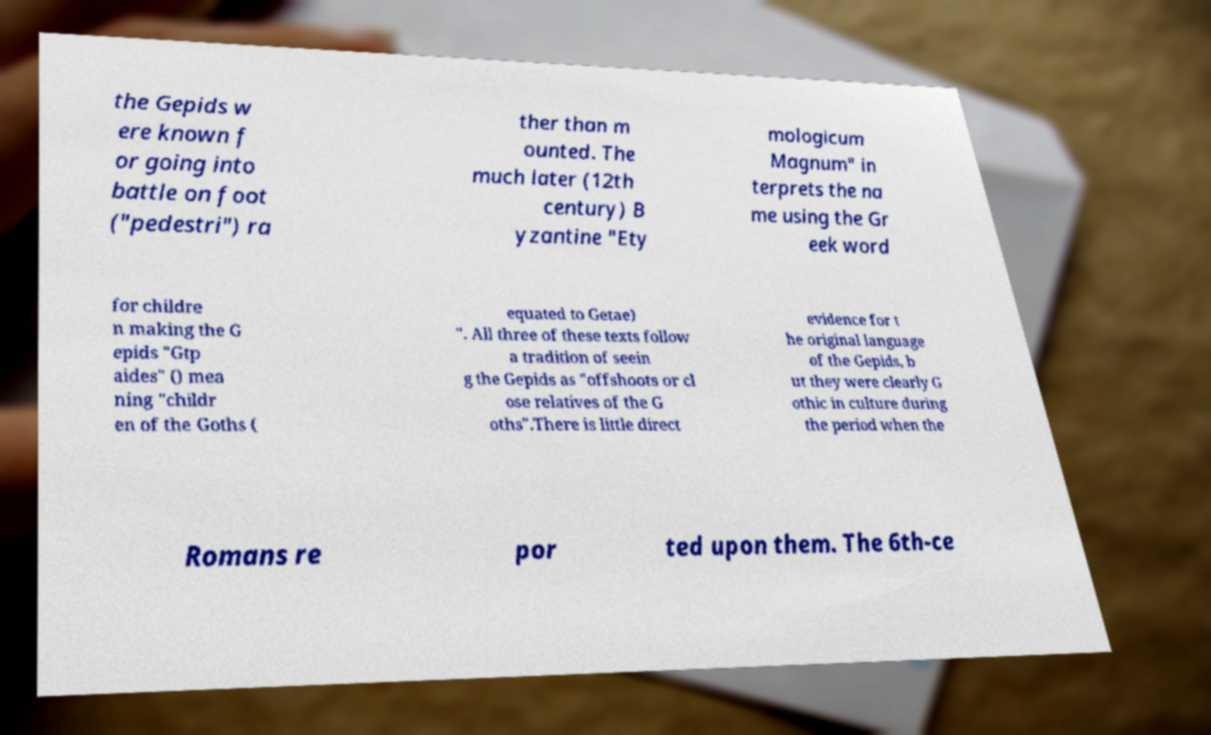Could you extract and type out the text from this image? the Gepids w ere known f or going into battle on foot ("pedestri") ra ther than m ounted. The much later (12th century) B yzantine "Ety mologicum Magnum" in terprets the na me using the Gr eek word for childre n making the G epids "Gtp aides" () mea ning "childr en of the Goths ( equated to Getae) ". All three of these texts follow a tradition of seein g the Gepids as "offshoots or cl ose relatives of the G oths".There is little direct evidence for t he original language of the Gepids, b ut they were clearly G othic in culture during the period when the Romans re por ted upon them. The 6th-ce 